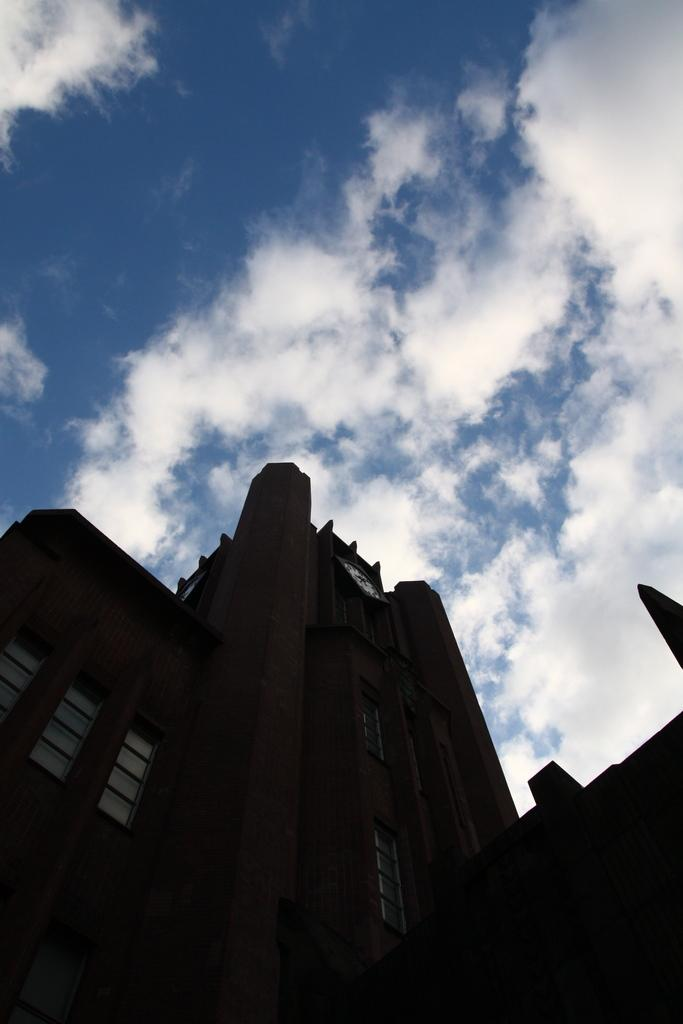What type of structure is present in the image? There is a building in the image. What feature can be seen on the building? The building has windows. Is there any specific detail on the building? Yes, there is a clock on the building. What can be seen in the background of the image? The sky is visible in the background of the image. How would you describe the weather based on the sky? The sky appears to be cloudy. How does the earthquake affect the slope of the building in the image? There is no earthquake or slope mentioned in the image. The building is standing upright, and there is no indication of any seismic activity or sloping ground. 